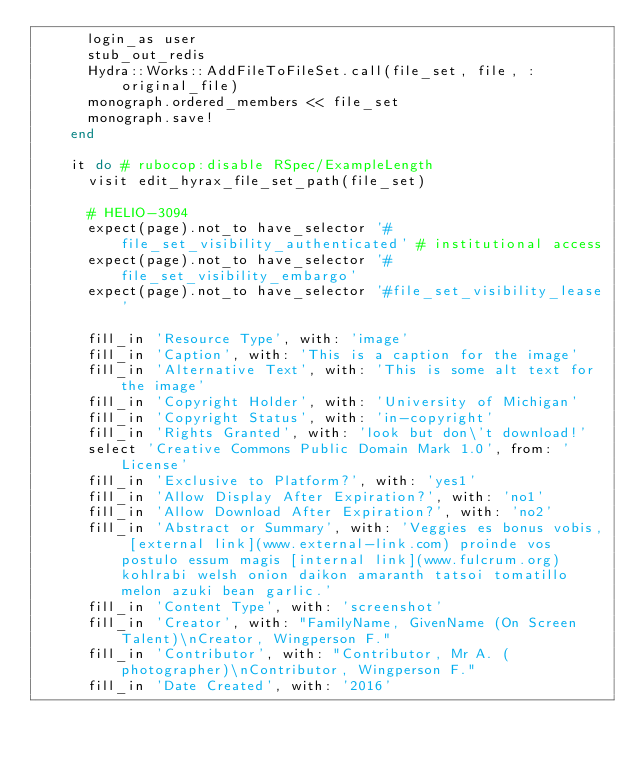Convert code to text. <code><loc_0><loc_0><loc_500><loc_500><_Ruby_>      login_as user
      stub_out_redis
      Hydra::Works::AddFileToFileSet.call(file_set, file, :original_file)
      monograph.ordered_members << file_set
      monograph.save!
    end

    it do # rubocop:disable RSpec/ExampleLength
      visit edit_hyrax_file_set_path(file_set)

      # HELIO-3094
      expect(page).not_to have_selector '#file_set_visibility_authenticated' # institutional access
      expect(page).not_to have_selector '#file_set_visibility_embargo'
      expect(page).not_to have_selector '#file_set_visibility_lease'

      fill_in 'Resource Type', with: 'image'
      fill_in 'Caption', with: 'This is a caption for the image'
      fill_in 'Alternative Text', with: 'This is some alt text for the image'
      fill_in 'Copyright Holder', with: 'University of Michigan'
      fill_in 'Copyright Status', with: 'in-copyright'
      fill_in 'Rights Granted', with: 'look but don\'t download!'
      select 'Creative Commons Public Domain Mark 1.0', from: 'License'
      fill_in 'Exclusive to Platform?', with: 'yes1'
      fill_in 'Allow Display After Expiration?', with: 'no1'
      fill_in 'Allow Download After Expiration?', with: 'no2'
      fill_in 'Abstract or Summary', with: 'Veggies es bonus vobis, [external link](www.external-link.com) proinde vos postulo essum magis [internal link](www.fulcrum.org) kohlrabi welsh onion daikon amaranth tatsoi tomatillo melon azuki bean garlic.'
      fill_in 'Content Type', with: 'screenshot'
      fill_in 'Creator', with: "FamilyName, GivenName (On Screen Talent)\nCreator, Wingperson F."
      fill_in 'Contributor', with: "Contributor, Mr A. (photographer)\nContributor, Wingperson F."
      fill_in 'Date Created', with: '2016'</code> 